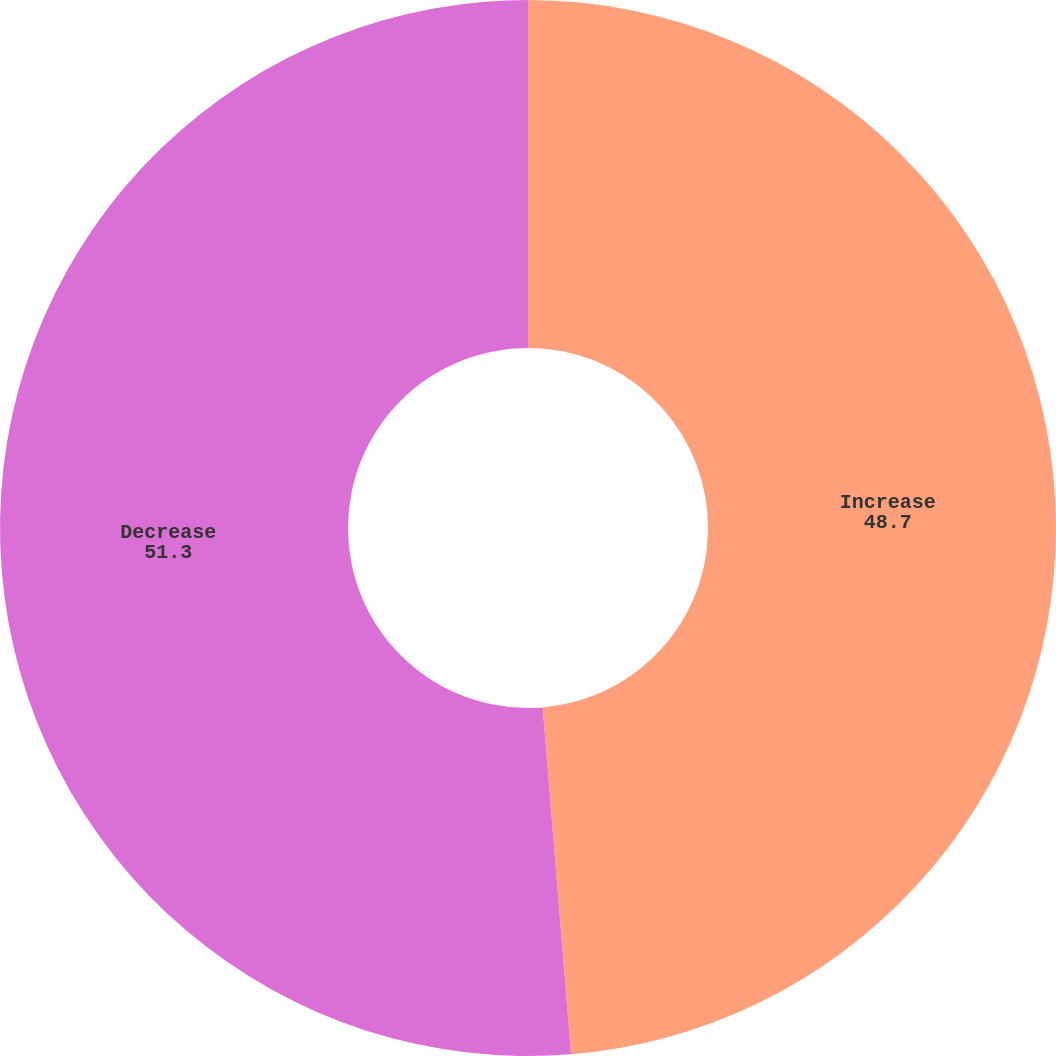Convert chart. <chart><loc_0><loc_0><loc_500><loc_500><pie_chart><fcel>Increase<fcel>Decrease<nl><fcel>48.7%<fcel>51.3%<nl></chart> 